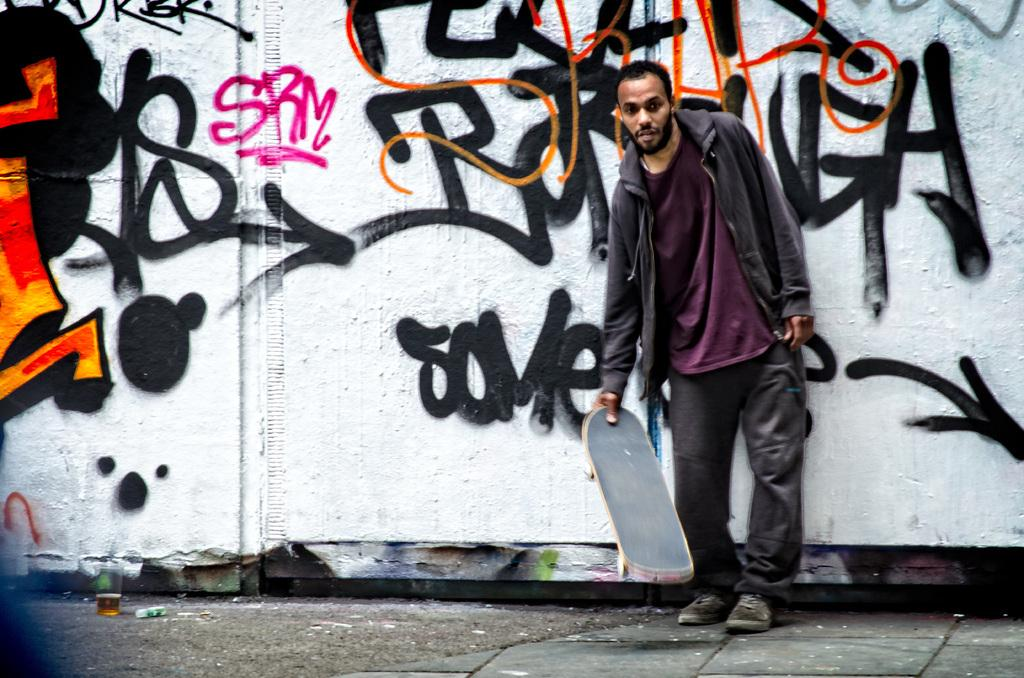Who or what is present in the image? There is a person in the image. What is the person holding? The person is holding a skateboard. What else can be seen on the ground in the image? There is a glass with a drink on the ground. What is visible in the background of the image? There is a wall with text in the background. How does the person use glue in the image? There is no glue present in the image, so it cannot be used by the person. 